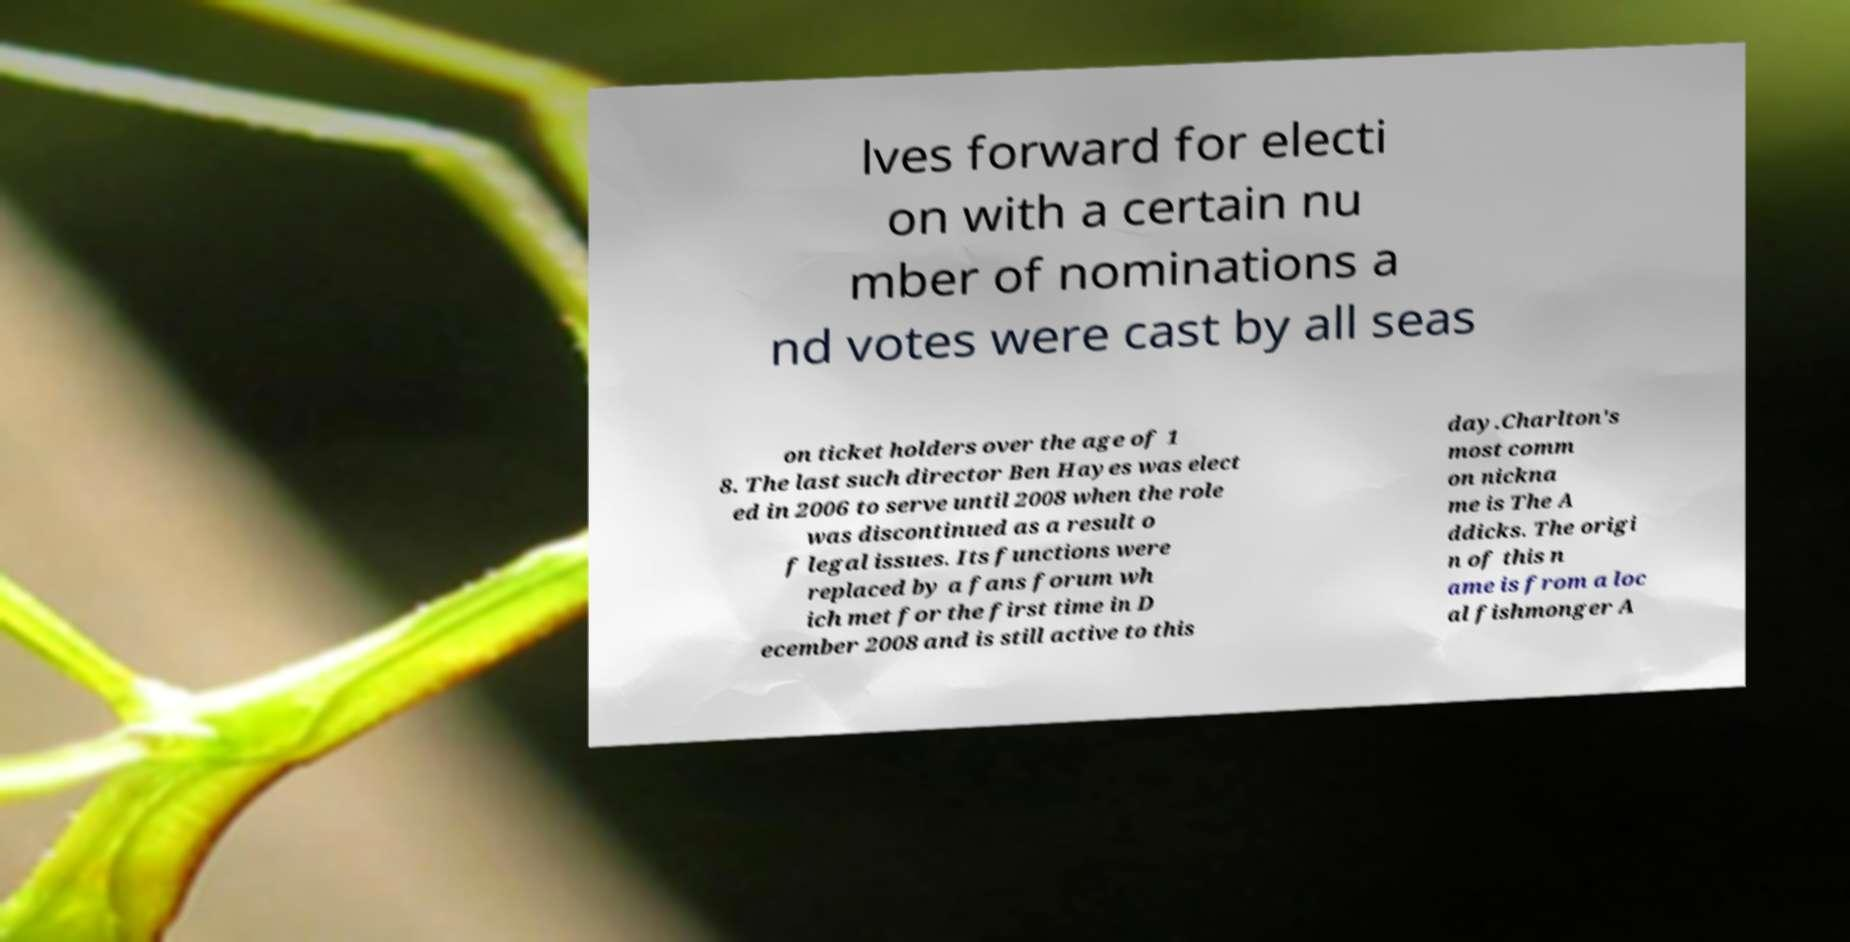For documentation purposes, I need the text within this image transcribed. Could you provide that? lves forward for electi on with a certain nu mber of nominations a nd votes were cast by all seas on ticket holders over the age of 1 8. The last such director Ben Hayes was elect ed in 2006 to serve until 2008 when the role was discontinued as a result o f legal issues. Its functions were replaced by a fans forum wh ich met for the first time in D ecember 2008 and is still active to this day.Charlton's most comm on nickna me is The A ddicks. The origi n of this n ame is from a loc al fishmonger A 